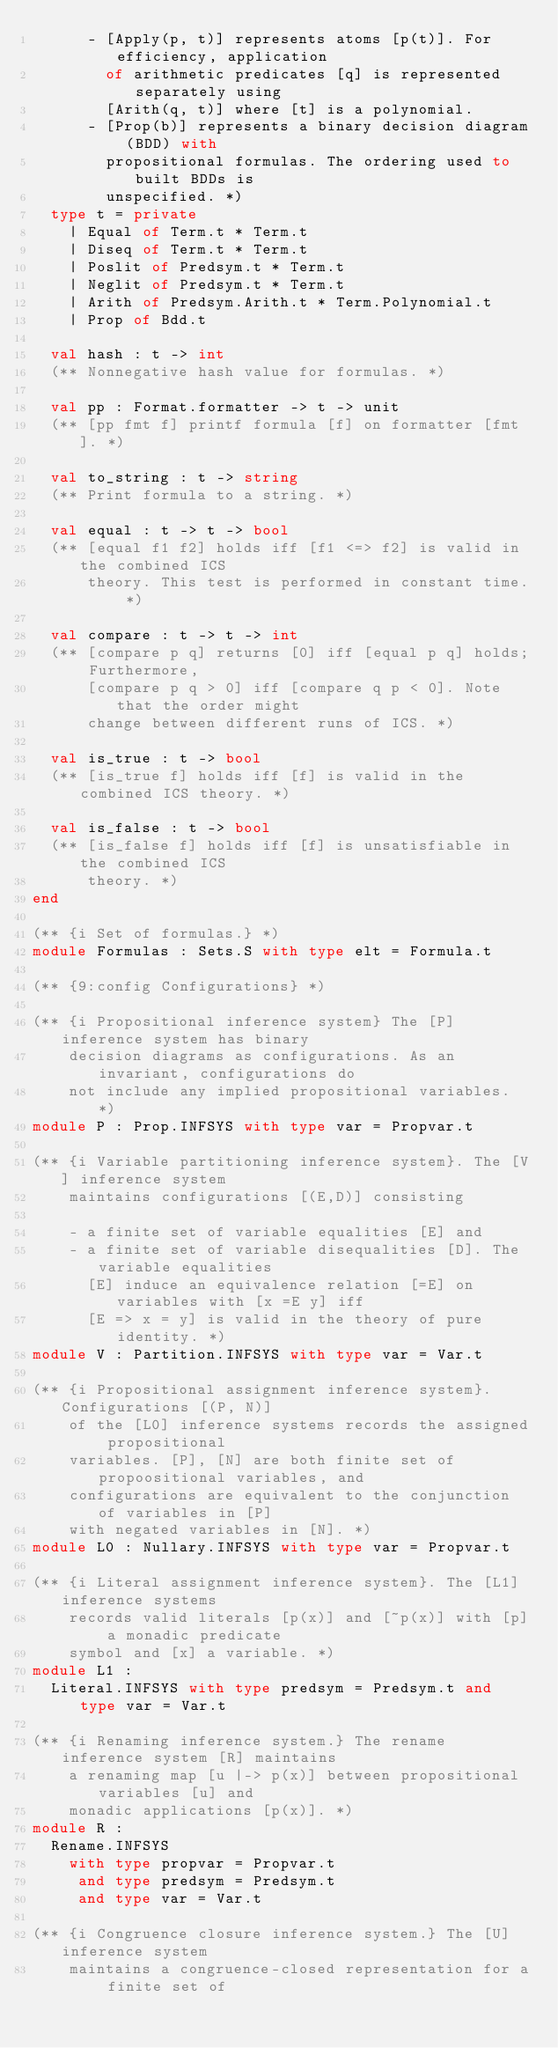<code> <loc_0><loc_0><loc_500><loc_500><_OCaml_>      - [Apply(p, t)] represents atoms [p(t)]. For efficiency, application
        of arithmetic predicates [q] is represented separately using
        [Arith(q, t)] where [t] is a polynomial.
      - [Prop(b)] represents a binary decision diagram (BDD) with
        propositional formulas. The ordering used to built BDDs is
        unspecified. *)
  type t = private
    | Equal of Term.t * Term.t
    | Diseq of Term.t * Term.t
    | Poslit of Predsym.t * Term.t
    | Neglit of Predsym.t * Term.t
    | Arith of Predsym.Arith.t * Term.Polynomial.t
    | Prop of Bdd.t

  val hash : t -> int
  (** Nonnegative hash value for formulas. *)

  val pp : Format.formatter -> t -> unit
  (** [pp fmt f] printf formula [f] on formatter [fmt]. *)

  val to_string : t -> string
  (** Print formula to a string. *)

  val equal : t -> t -> bool
  (** [equal f1 f2] holds iff [f1 <=> f2] is valid in the combined ICS
      theory. This test is performed in constant time. *)

  val compare : t -> t -> int
  (** [compare p q] returns [0] iff [equal p q] holds; Furthermore,
      [compare p q > 0] iff [compare q p < 0]. Note that the order might
      change between different runs of ICS. *)

  val is_true : t -> bool
  (** [is_true f] holds iff [f] is valid in the combined ICS theory. *)

  val is_false : t -> bool
  (** [is_false f] holds iff [f] is unsatisfiable in the combined ICS
      theory. *)
end

(** {i Set of formulas.} *)
module Formulas : Sets.S with type elt = Formula.t

(** {9:config Configurations} *)

(** {i Propositional inference system} The [P] inference system has binary
    decision diagrams as configurations. As an invariant, configurations do
    not include any implied propositional variables. *)
module P : Prop.INFSYS with type var = Propvar.t

(** {i Variable partitioning inference system}. The [V] inference system
    maintains configurations [(E,D)] consisting

    - a finite set of variable equalities [E] and
    - a finite set of variable disequalities [D]. The variable equalities
      [E] induce an equivalence relation [=E] on variables with [x =E y] iff
      [E => x = y] is valid in the theory of pure identity. *)
module V : Partition.INFSYS with type var = Var.t

(** {i Propositional assignment inference system}. Configurations [(P, N)]
    of the [L0] inference systems records the assigned propositional
    variables. [P], [N] are both finite set of propoositional variables, and
    configurations are equivalent to the conjunction of variables in [P]
    with negated variables in [N]. *)
module L0 : Nullary.INFSYS with type var = Propvar.t

(** {i Literal assignment inference system}. The [L1] inference systems
    records valid literals [p(x)] and [~p(x)] with [p] a monadic predicate
    symbol and [x] a variable. *)
module L1 :
  Literal.INFSYS with type predsym = Predsym.t and type var = Var.t

(** {i Renaming inference system.} The rename inference system [R] maintains
    a renaming map [u |-> p(x)] between propositional variables [u] and
    monadic applications [p(x)]. *)
module R :
  Rename.INFSYS
    with type propvar = Propvar.t
     and type predsym = Predsym.t
     and type var = Var.t

(** {i Congruence closure inference system.} The [U] inference system
    maintains a congruence-closed representation for a finite set of</code> 